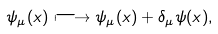Convert formula to latex. <formula><loc_0><loc_0><loc_500><loc_500>\psi _ { \mu } ( x ) \longmapsto \psi _ { \mu } ( x ) + \delta _ { \mu } \psi ( x ) ,</formula> 